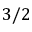Convert formula to latex. <formula><loc_0><loc_0><loc_500><loc_500>3 / 2</formula> 